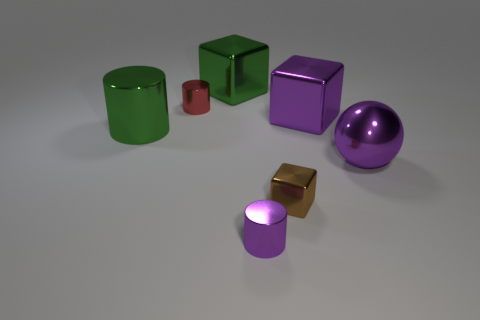Add 1 red things. How many objects exist? 8 Subtract all cylinders. How many objects are left? 4 Add 5 large objects. How many large objects exist? 9 Subtract 0 blue balls. How many objects are left? 7 Subtract all big purple metallic spheres. Subtract all purple things. How many objects are left? 3 Add 7 small metal cubes. How many small metal cubes are left? 8 